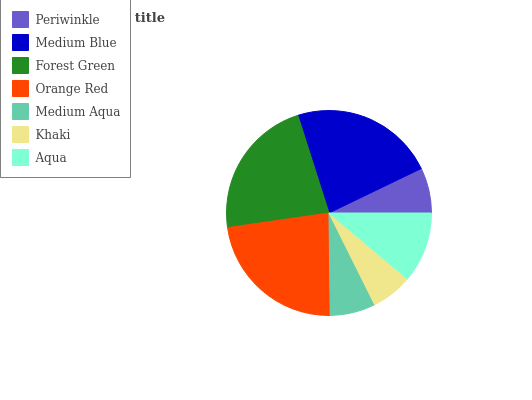Is Khaki the minimum?
Answer yes or no. Yes. Is Orange Red the maximum?
Answer yes or no. Yes. Is Medium Blue the minimum?
Answer yes or no. No. Is Medium Blue the maximum?
Answer yes or no. No. Is Medium Blue greater than Periwinkle?
Answer yes or no. Yes. Is Periwinkle less than Medium Blue?
Answer yes or no. Yes. Is Periwinkle greater than Medium Blue?
Answer yes or no. No. Is Medium Blue less than Periwinkle?
Answer yes or no. No. Is Aqua the high median?
Answer yes or no. Yes. Is Aqua the low median?
Answer yes or no. Yes. Is Medium Blue the high median?
Answer yes or no. No. Is Khaki the low median?
Answer yes or no. No. 